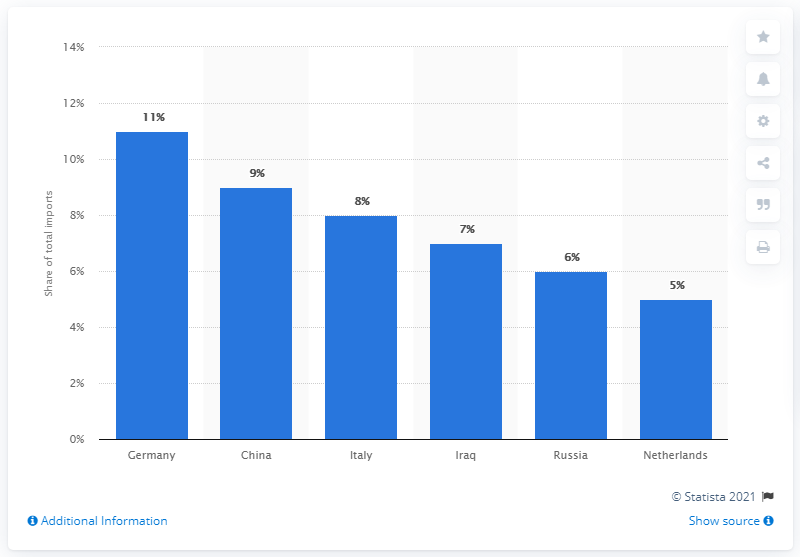Indicate a few pertinent items in this graphic. In 2019, Germany accounted for approximately 11% of total imports. In 2019, Germany was Greece's primary import partner. 